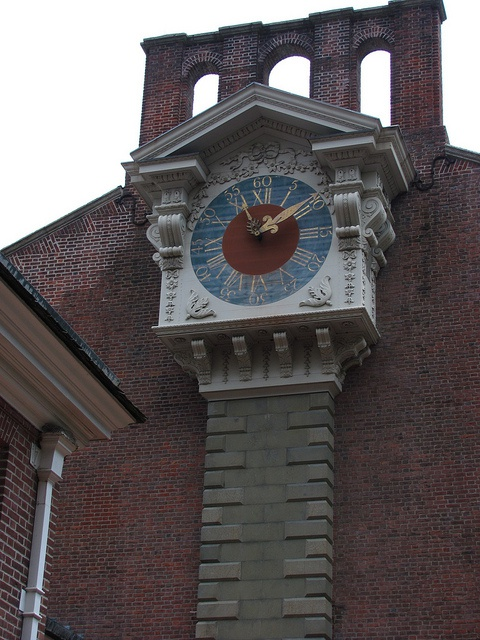Describe the objects in this image and their specific colors. I can see a clock in white, gray, blue, maroon, and darkgray tones in this image. 